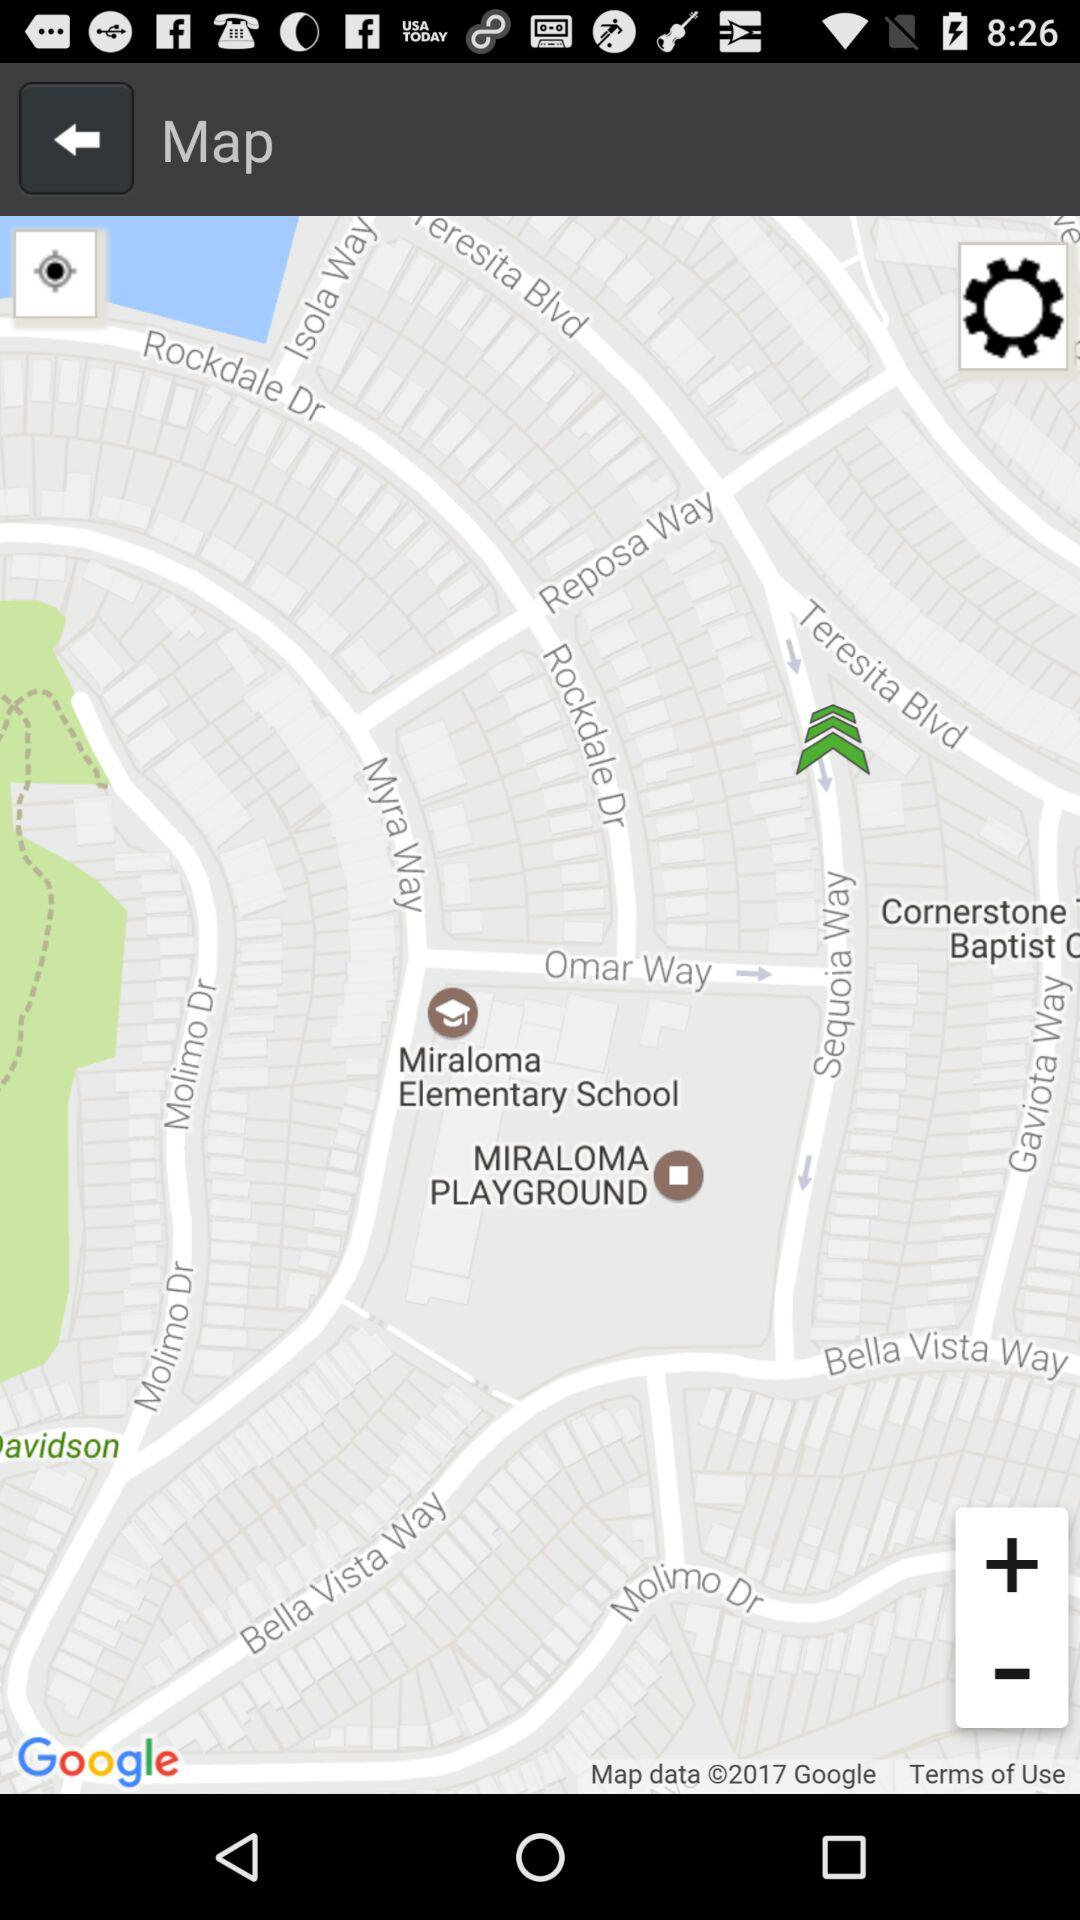What is the app name?
When the provided information is insufficient, respond with <no answer>. <no answer> 